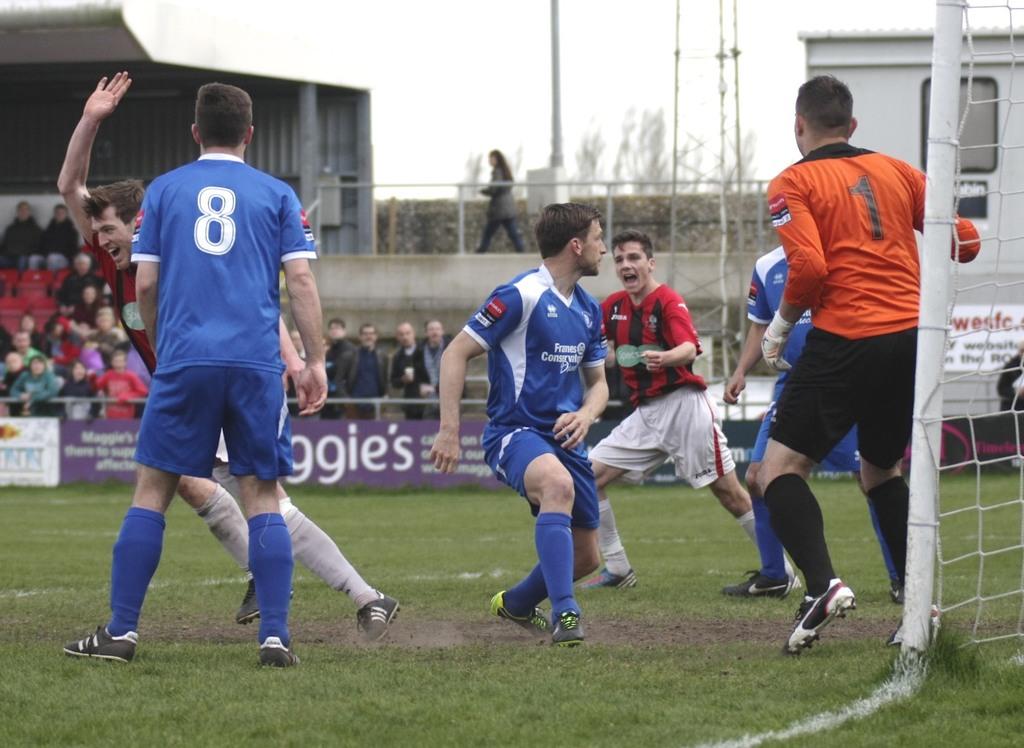What number is the man in orange?
Your answer should be compact. 1. 